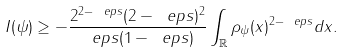<formula> <loc_0><loc_0><loc_500><loc_500>I ( \psi ) \geq - \frac { 2 ^ { 2 - \ e p s } ( 2 - \ e p s ) ^ { 2 } } { \ e p s ( 1 - \ e p s ) } \int _ { \mathbb { R } } \rho _ { \psi } ( x ) ^ { 2 - \ e p s } d x .</formula> 